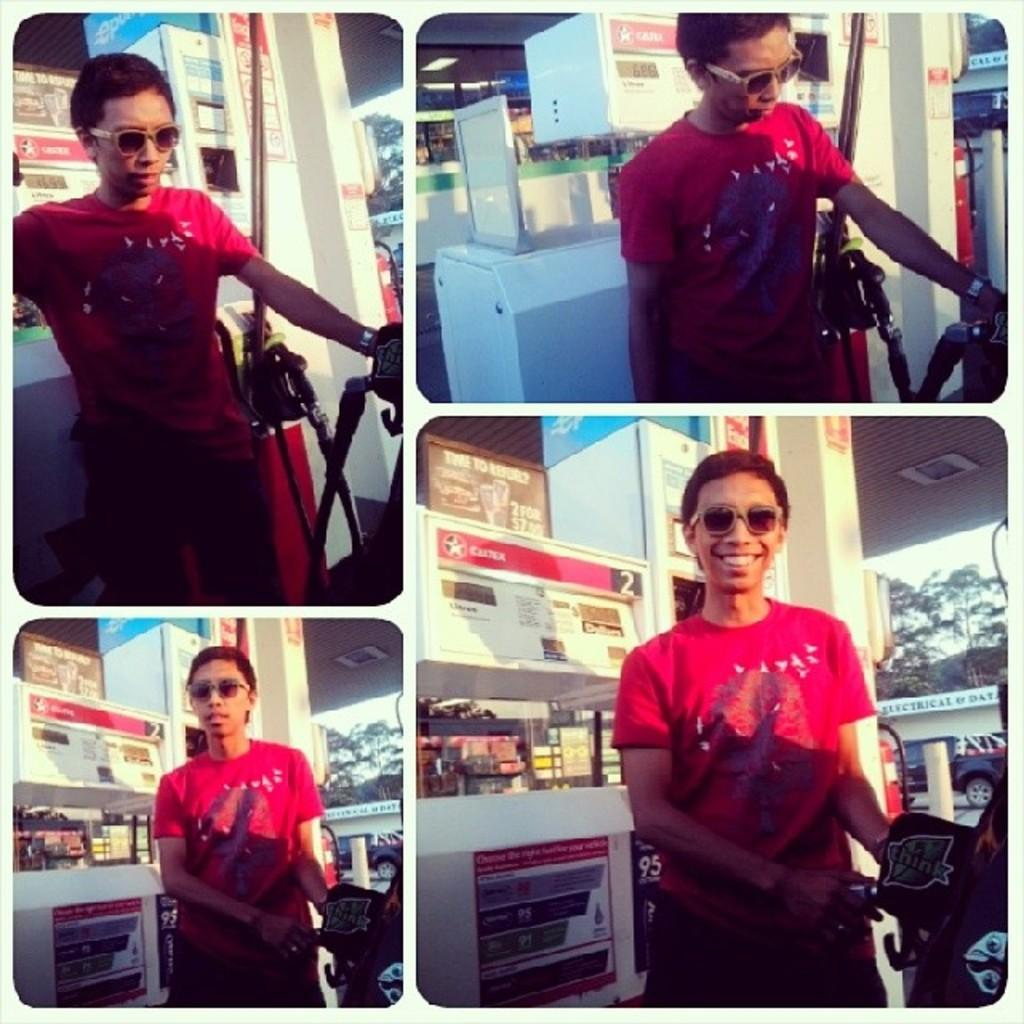Who is present in the image? There is a person in the image. What is the person wearing on their upper body? The person is wearing a red T-shirt. What protective gear is the person wearing? The person is wearing goggles. What accessory is the person wearing on their wrist? The person is wearing a watch. Where is the person standing in the image? The person is standing near a gas filling station. What type of tooth is visible in the image? There is no tooth present in the image. Is there a desk in the image? There is no desk present in the image. 